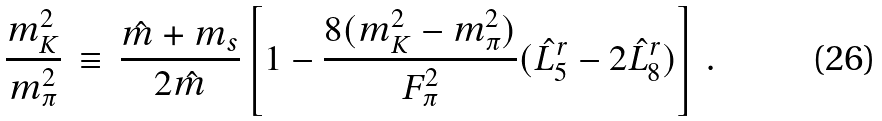<formula> <loc_0><loc_0><loc_500><loc_500>\frac { m _ { K } ^ { 2 } } { m _ { \pi } ^ { 2 } } \, \equiv \, \frac { \hat { m } + m _ { s } } { 2 \hat { m } } \left [ 1 - \frac { 8 ( m _ { K } ^ { 2 } - m _ { \pi } ^ { 2 } ) } { F _ { \pi } ^ { 2 } } ( \hat { L } _ { 5 } ^ { r } - 2 \hat { L } _ { 8 } ^ { r } ) \right ] \, .</formula> 